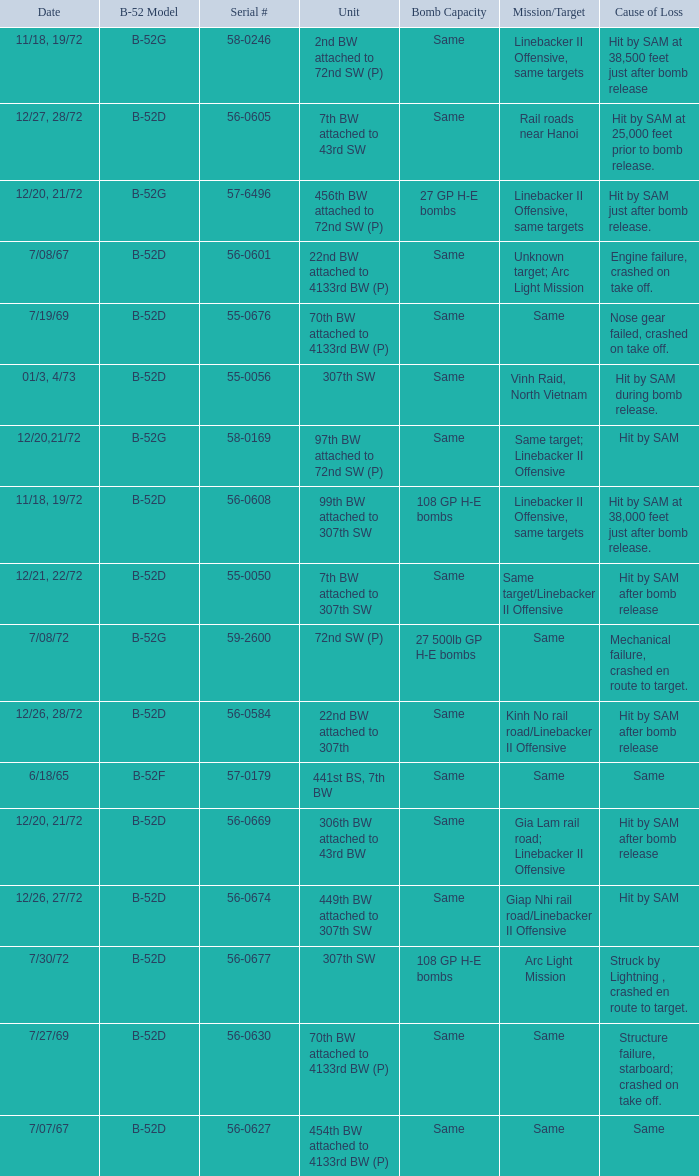Would you be able to parse every entry in this table? {'header': ['Date', 'B-52 Model', 'Serial #', 'Unit', 'Bomb Capacity', 'Mission/Target', 'Cause of Loss'], 'rows': [['11/18, 19/72', 'B-52G', '58-0246', '2nd BW attached to 72nd SW (P)', 'Same', 'Linebacker II Offensive, same targets', 'Hit by SAM at 38,500 feet just after bomb release'], ['12/27, 28/72', 'B-52D', '56-0605', '7th BW attached to 43rd SW', 'Same', 'Rail roads near Hanoi', 'Hit by SAM at 25,000 feet prior to bomb release.'], ['12/20, 21/72', 'B-52G', '57-6496', '456th BW attached to 72nd SW (P)', '27 GP H-E bombs', 'Linebacker II Offensive, same targets', 'Hit by SAM just after bomb release.'], ['7/08/67', 'B-52D', '56-0601', '22nd BW attached to 4133rd BW (P)', 'Same', 'Unknown target; Arc Light Mission', 'Engine failure, crashed on take off.'], ['7/19/69', 'B-52D', '55-0676', '70th BW attached to 4133rd BW (P)', 'Same', 'Same', 'Nose gear failed, crashed on take off.'], ['01/3, 4/73', 'B-52D', '55-0056', '307th SW', 'Same', 'Vinh Raid, North Vietnam', 'Hit by SAM during bomb release.'], ['12/20,21/72', 'B-52G', '58-0169', '97th BW attached to 72nd SW (P)', 'Same', 'Same target; Linebacker II Offensive', 'Hit by SAM'], ['11/18, 19/72', 'B-52D', '56-0608', '99th BW attached to 307th SW', '108 GP H-E bombs', 'Linebacker II Offensive, same targets', 'Hit by SAM at 38,000 feet just after bomb release.'], ['12/21, 22/72', 'B-52D', '55-0050', '7th BW attached to 307th SW', 'Same', 'Same target/Linebacker II Offensive', 'Hit by SAM after bomb release'], ['7/08/72', 'B-52G', '59-2600', '72nd SW (P)', '27 500lb GP H-E bombs', 'Same', 'Mechanical failure, crashed en route to target.'], ['12/26, 28/72', 'B-52D', '56-0584', '22nd BW attached to 307th', 'Same', 'Kinh No rail road/Linebacker II Offensive', 'Hit by SAM after bomb release'], ['6/18/65', 'B-52F', '57-0179', '441st BS, 7th BW', 'Same', 'Same', 'Same'], ['12/20, 21/72', 'B-52D', '56-0669', '306th BW attached to 43rd BW', 'Same', 'Gia Lam rail road; Linebacker II Offensive', 'Hit by SAM after bomb release'], ['12/26, 27/72', 'B-52D', '56-0674', '449th BW attached to 307th SW', 'Same', 'Giap Nhi rail road/Linebacker II Offensive', 'Hit by SAM'], ['7/30/72', 'B-52D', '56-0677', '307th SW', '108 GP H-E bombs', 'Arc Light Mission', 'Struck by Lightning , crashed en route to target.'], ['7/27/69', 'B-52D', '56-0630', '70th BW attached to 4133rd BW (P)', 'Same', 'Same', 'Structure failure, starboard; crashed on take off.'], ['7/07/67', 'B-52D', '56-0627', '454th BW attached to 4133rd BW (P)', 'Same', 'Same', 'Same']]} When  27 gp h-e bombs the capacity of the bomb what is the cause of loss? Hit by SAM just after bomb release. 